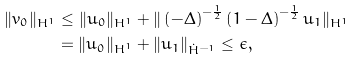<formula> <loc_0><loc_0><loc_500><loc_500>\| v _ { 0 } \| _ { H ^ { 1 } } & \leq \| u _ { 0 } \| _ { H ^ { 1 } } + \| \left ( - \Delta \right ) ^ { - \frac { 1 } { 2 } } \left ( 1 - \Delta \right ) ^ { - \frac { 1 } { 2 } } u _ { 1 } \| _ { H ^ { 1 } } \\ & = \| u _ { 0 } \| _ { H ^ { 1 } } + \| u _ { 1 } \| _ { \dot { H } ^ { - 1 } } \leq \epsilon ,</formula> 